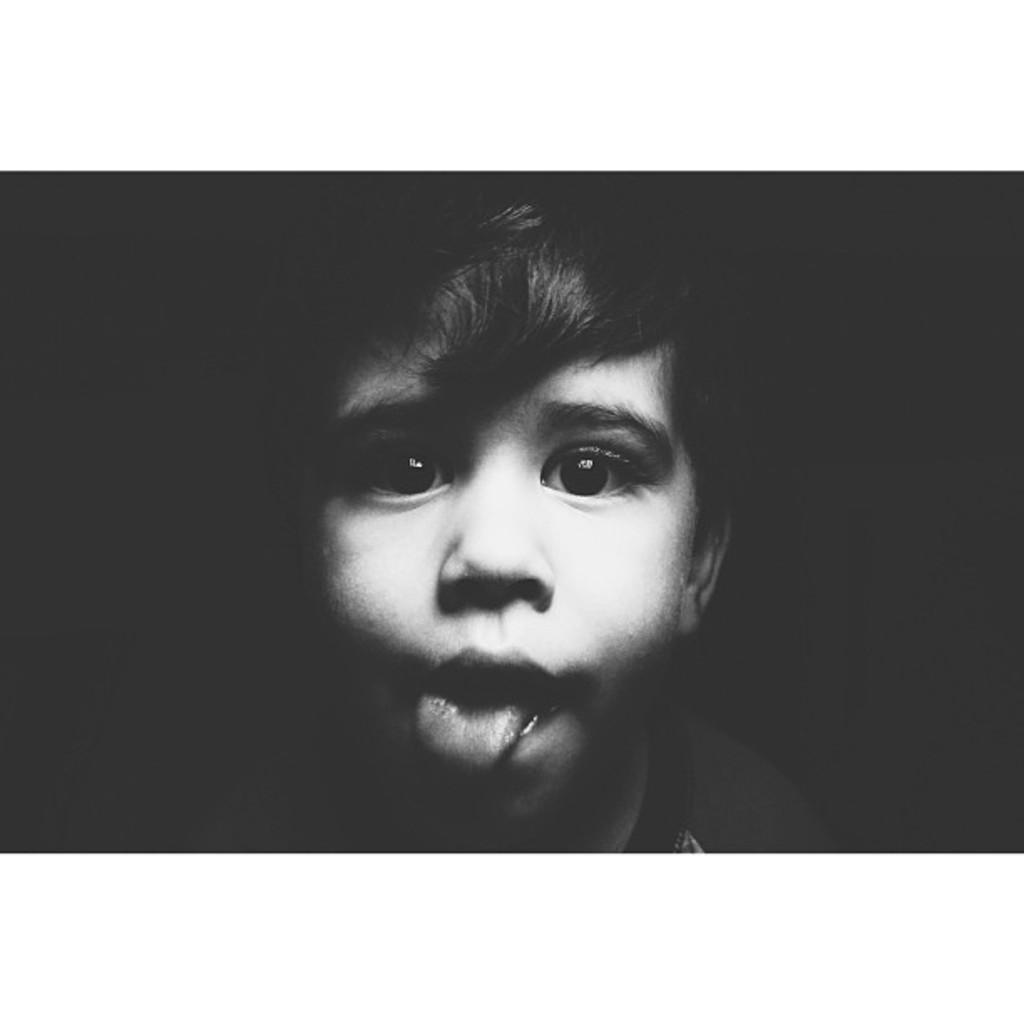How would you summarize this image in a sentence or two? In this picture we can see a child and in the background it is dark. 